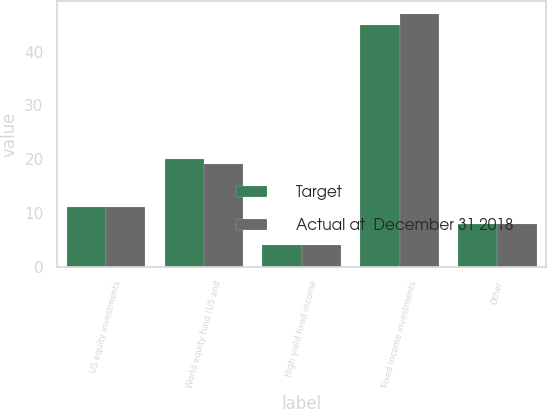<chart> <loc_0><loc_0><loc_500><loc_500><stacked_bar_chart><ecel><fcel>US equity investments<fcel>World equity fund (US and<fcel>High yield fixed income<fcel>Fixed income investments<fcel>Other<nl><fcel>Target<fcel>11<fcel>20<fcel>4<fcel>45<fcel>8<nl><fcel>Actual at  December 31 2018<fcel>11<fcel>19<fcel>4<fcel>47<fcel>8<nl></chart> 